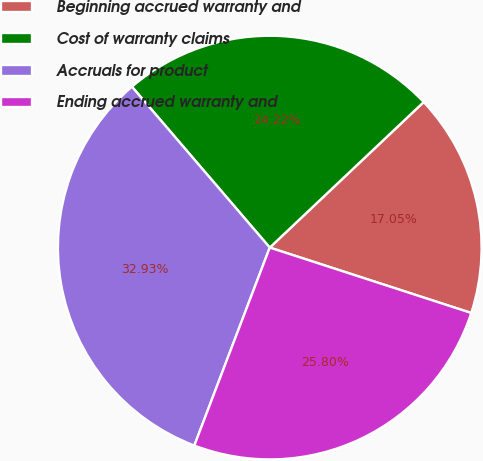Convert chart to OTSL. <chart><loc_0><loc_0><loc_500><loc_500><pie_chart><fcel>Beginning accrued warranty and<fcel>Cost of warranty claims<fcel>Accruals for product<fcel>Ending accrued warranty and<nl><fcel>17.05%<fcel>24.22%<fcel>32.93%<fcel>25.8%<nl></chart> 